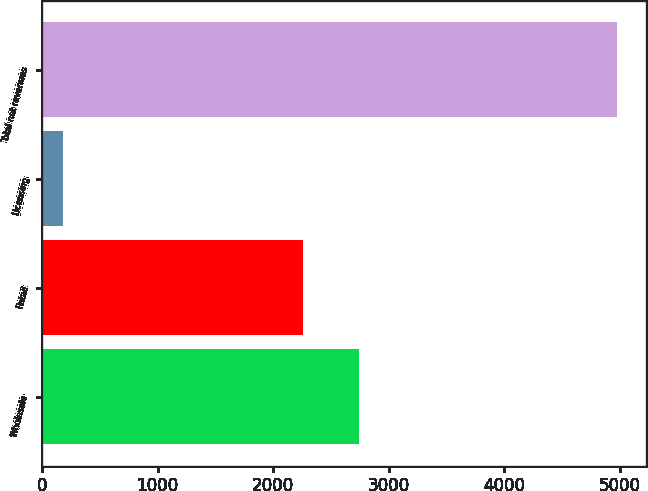Convert chart. <chart><loc_0><loc_0><loc_500><loc_500><bar_chart><fcel>Wholesale<fcel>Retail<fcel>Licensing<fcel>Total net revenues<nl><fcel>2742.65<fcel>2263.1<fcel>183.4<fcel>4978.9<nl></chart> 